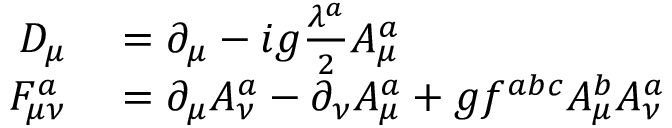<formula> <loc_0><loc_0><loc_500><loc_500>\begin{array} { r l } { D _ { \mu } } & = \partial _ { \mu } - i g \frac { \lambda ^ { a } } { 2 } A _ { \mu } ^ { a } } \\ { F _ { \mu \nu } ^ { a } } & = \partial _ { \mu } A _ { \nu } ^ { a } - \partial _ { \nu } A _ { \mu } ^ { a } + g f ^ { a b c } A _ { \mu } ^ { b } A _ { \nu } ^ { a } } \end{array}</formula> 